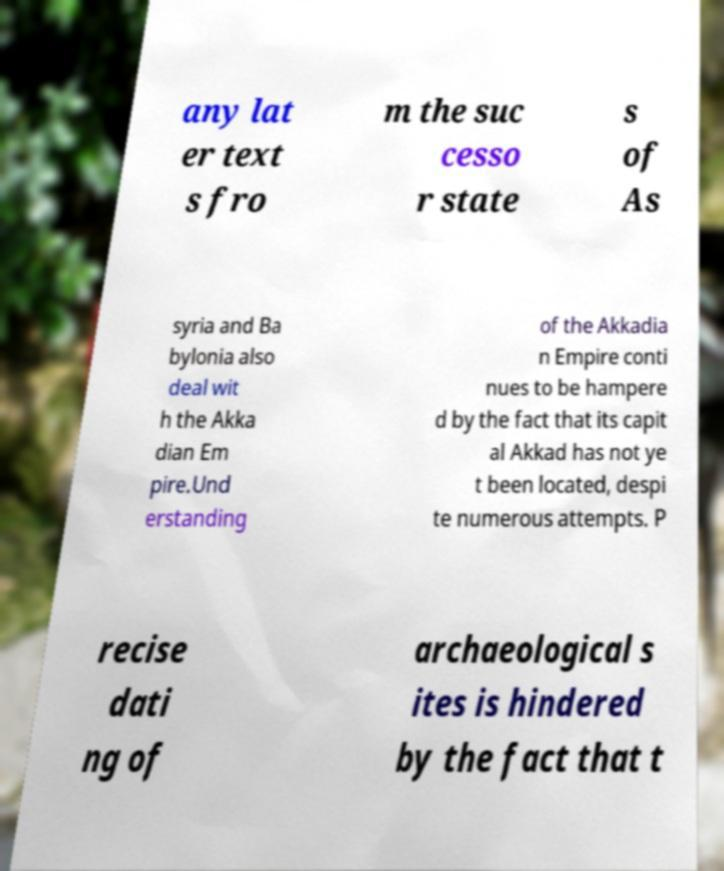For documentation purposes, I need the text within this image transcribed. Could you provide that? any lat er text s fro m the suc cesso r state s of As syria and Ba bylonia also deal wit h the Akka dian Em pire.Und erstanding of the Akkadia n Empire conti nues to be hampere d by the fact that its capit al Akkad has not ye t been located, despi te numerous attempts. P recise dati ng of archaeological s ites is hindered by the fact that t 